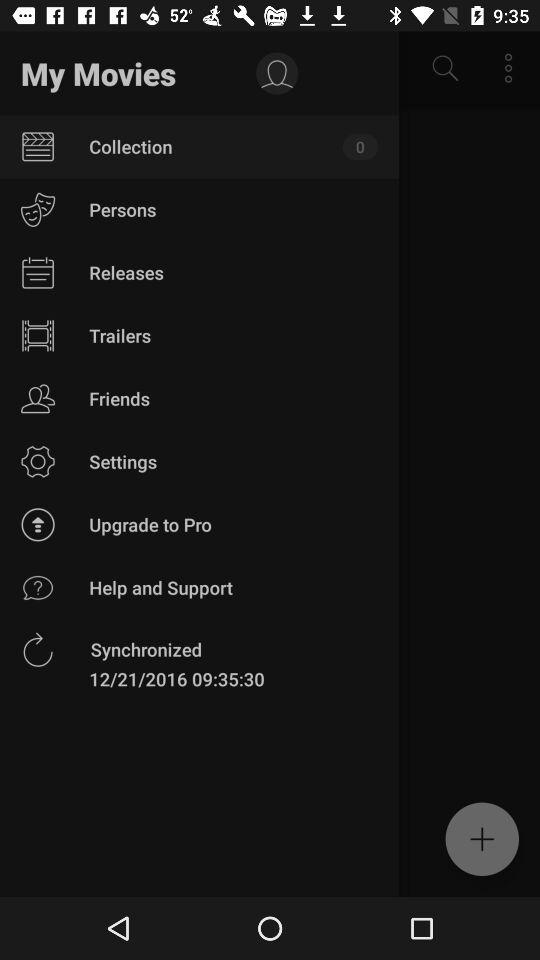What is the date of synchronization? The date of synchronization is December 21, 2016. 